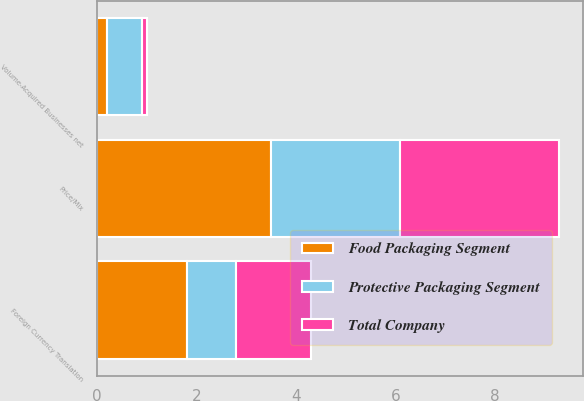Convert chart to OTSL. <chart><loc_0><loc_0><loc_500><loc_500><stacked_bar_chart><ecel><fcel>Volume-Acquired Businesses net<fcel>Price/Mix<fcel>Foreign Currency Translation<nl><fcel>Food Packaging Segment<fcel>0.2<fcel>3.5<fcel>1.8<nl><fcel>Protective Packaging Segment<fcel>0.7<fcel>2.6<fcel>1<nl><fcel>Total Company<fcel>0.1<fcel>3.2<fcel>1.5<nl></chart> 